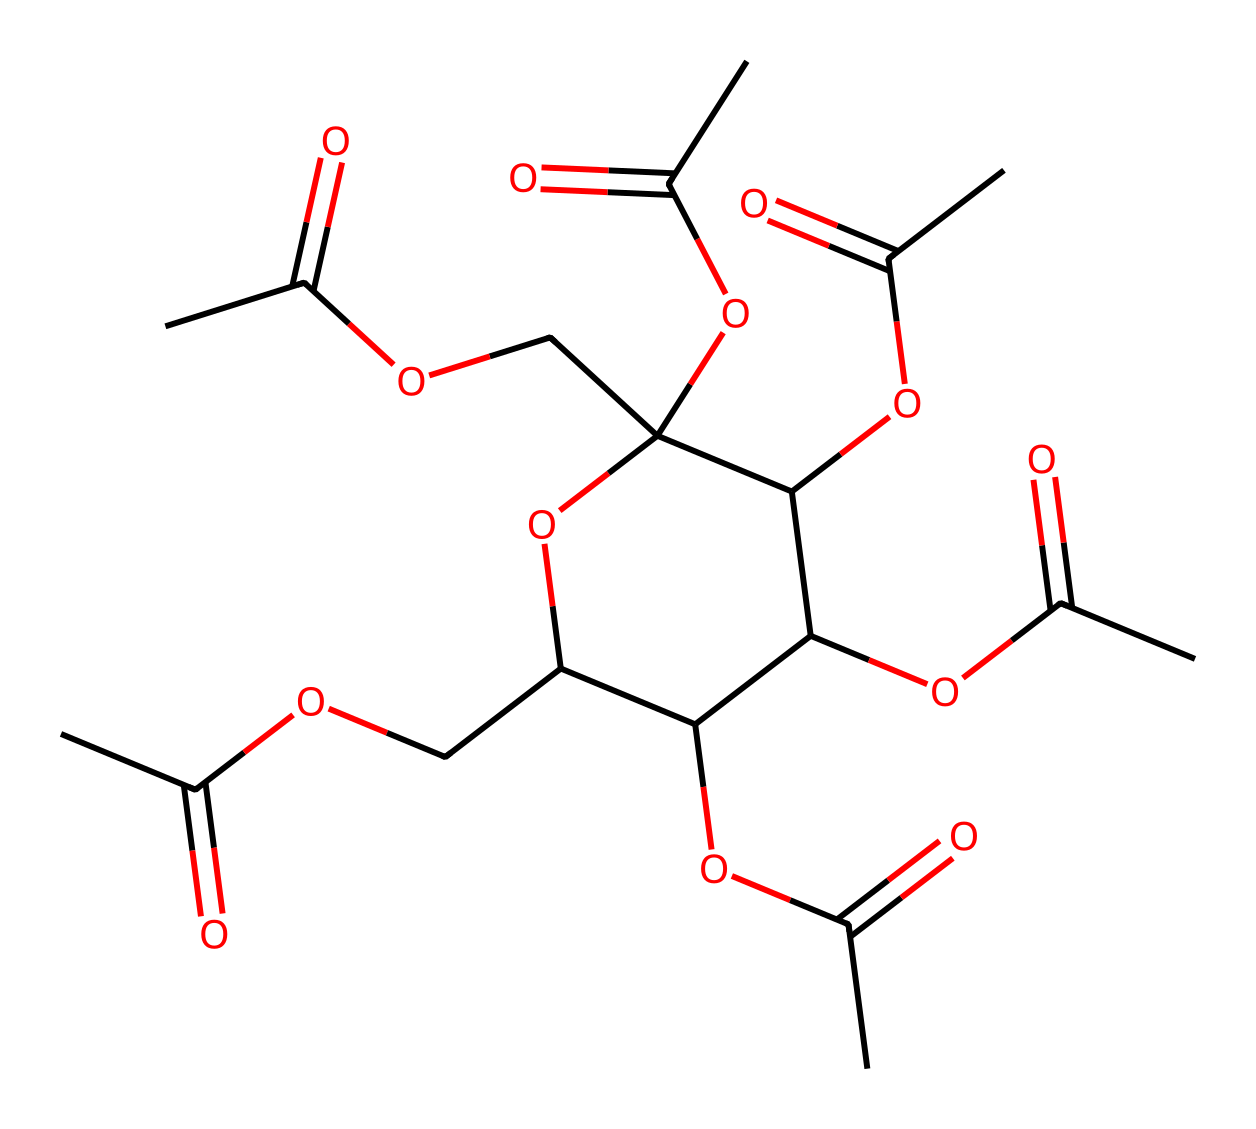What is the main functional group present in cellulose acetate? The main functional group in cellulose acetate is the ester group, which is characterized by the presence of a carbonyl (C=O) and an ether linkage (C-O). This can be confirmed by identifying the connections in the SMILES representation where carbonyl and ether structures appear.
Answer: ester group How many acetyl groups are present in the structure? The structure of cellulose acetate contains five acetyl groups, as seen in the multiple units of the structure where carbon atoms are attached to a carbonyl (C=O) and further connected to an oxygen. Each acetyl group can be identified as CH3CO-.
Answer: five What is the total number of oxygen atoms in the chemical structure? By analyzing the SMILES representation, there are 8 oxygen atoms present, which can be counted through the notation where 'O' appears. Each part of the structure that includes ether and carbonyl contributes to this count.
Answer: eight What type of polymer is cellulose acetate classified as? Cellulose acetate is classified as a thermoplastic polymer since it can be melted and remolded upon heating, due to its ester linkage structure derived from cellulose.
Answer: thermoplastic How many distinct rings are present in the structure? In this chemical structure, there is one distinct ring identified, which can be confirmed by observing the cyclic portion of the molecule where the connected carbon atoms form a closed loop.
Answer: one 